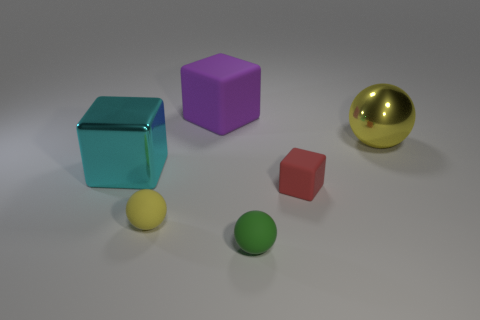Subtract all big blocks. How many blocks are left? 1 Subtract all red blocks. How many blocks are left? 2 Add 3 cubes. How many objects exist? 9 Subtract all yellow cylinders. How many yellow balls are left? 2 Subtract 2 cubes. How many cubes are left? 1 Subtract all yellow things. Subtract all tiny red rubber things. How many objects are left? 3 Add 4 yellow balls. How many yellow balls are left? 6 Add 4 tiny green rubber objects. How many tiny green rubber objects exist? 5 Subtract 0 brown spheres. How many objects are left? 6 Subtract all red blocks. Subtract all yellow cylinders. How many blocks are left? 2 